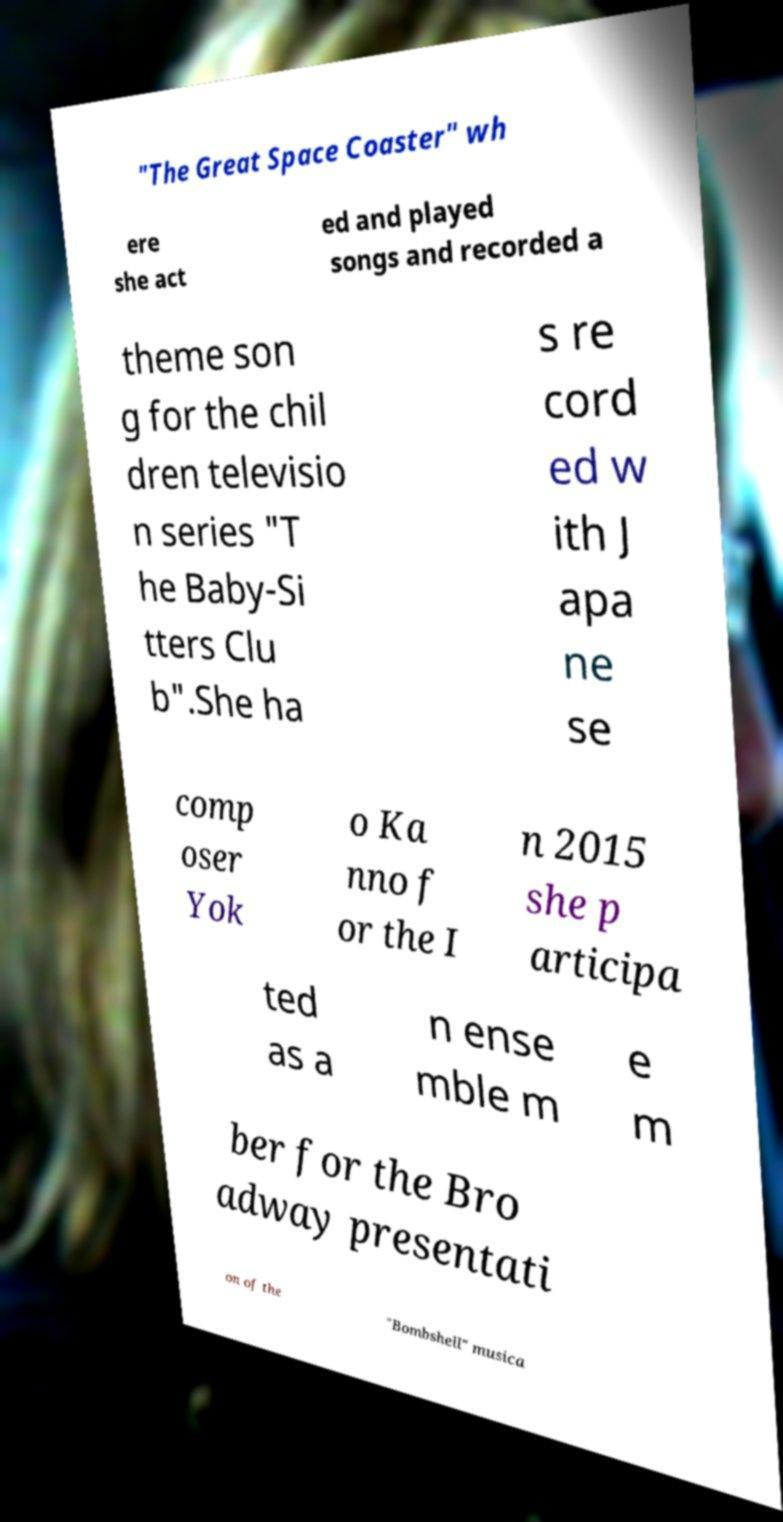Please identify and transcribe the text found in this image. "The Great Space Coaster" wh ere she act ed and played songs and recorded a theme son g for the chil dren televisio n series "T he Baby-Si tters Clu b".She ha s re cord ed w ith J apa ne se comp oser Yok o Ka nno f or the I n 2015 she p articipa ted as a n ense mble m e m ber for the Bro adway presentati on of the "Bombshell" musica 